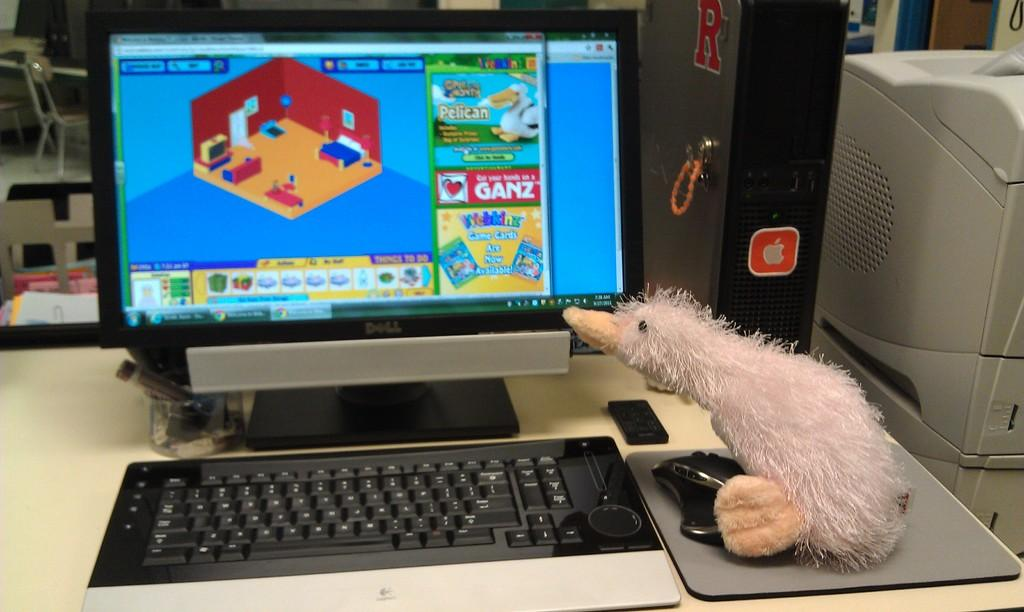<image>
Present a compact description of the photo's key features. A Ganz video game is displayed on the monitor. 